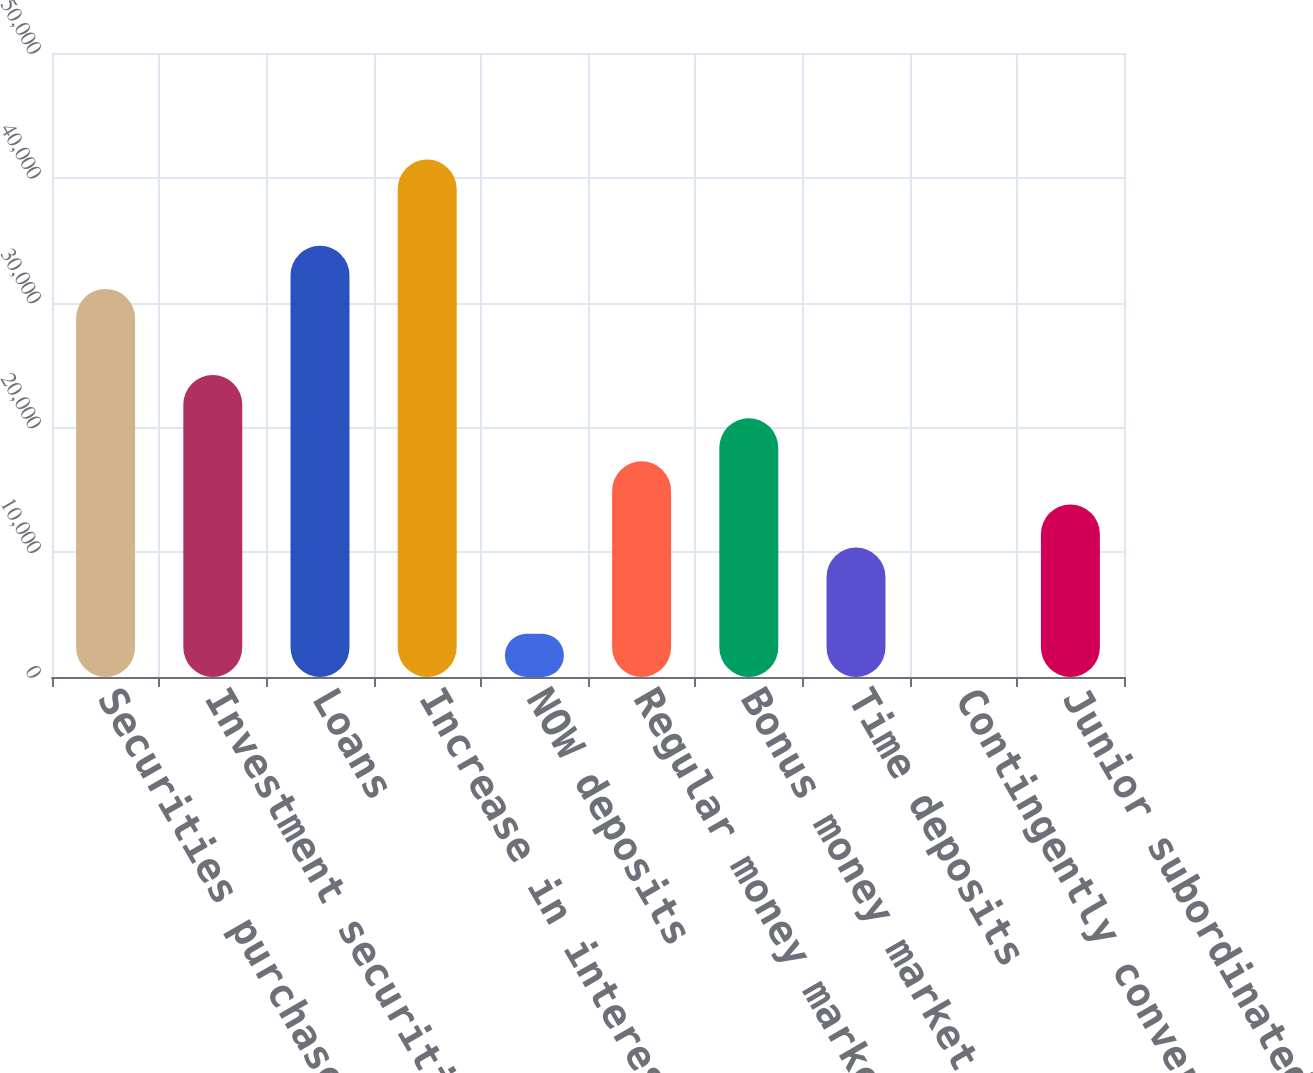Convert chart. <chart><loc_0><loc_0><loc_500><loc_500><bar_chart><fcel>Securities purchased under<fcel>Investment securities<fcel>Loans<fcel>Increase in interest income<fcel>NOW deposits<fcel>Regular money market deposits<fcel>Bonus money market deposits<fcel>Time deposits<fcel>Contingently convertible debt<fcel>Junior subordinated debentures<nl><fcel>31099.4<fcel>24190.2<fcel>34554<fcel>41463.2<fcel>3462.6<fcel>17281<fcel>20735.6<fcel>10371.8<fcel>8<fcel>13826.4<nl></chart> 